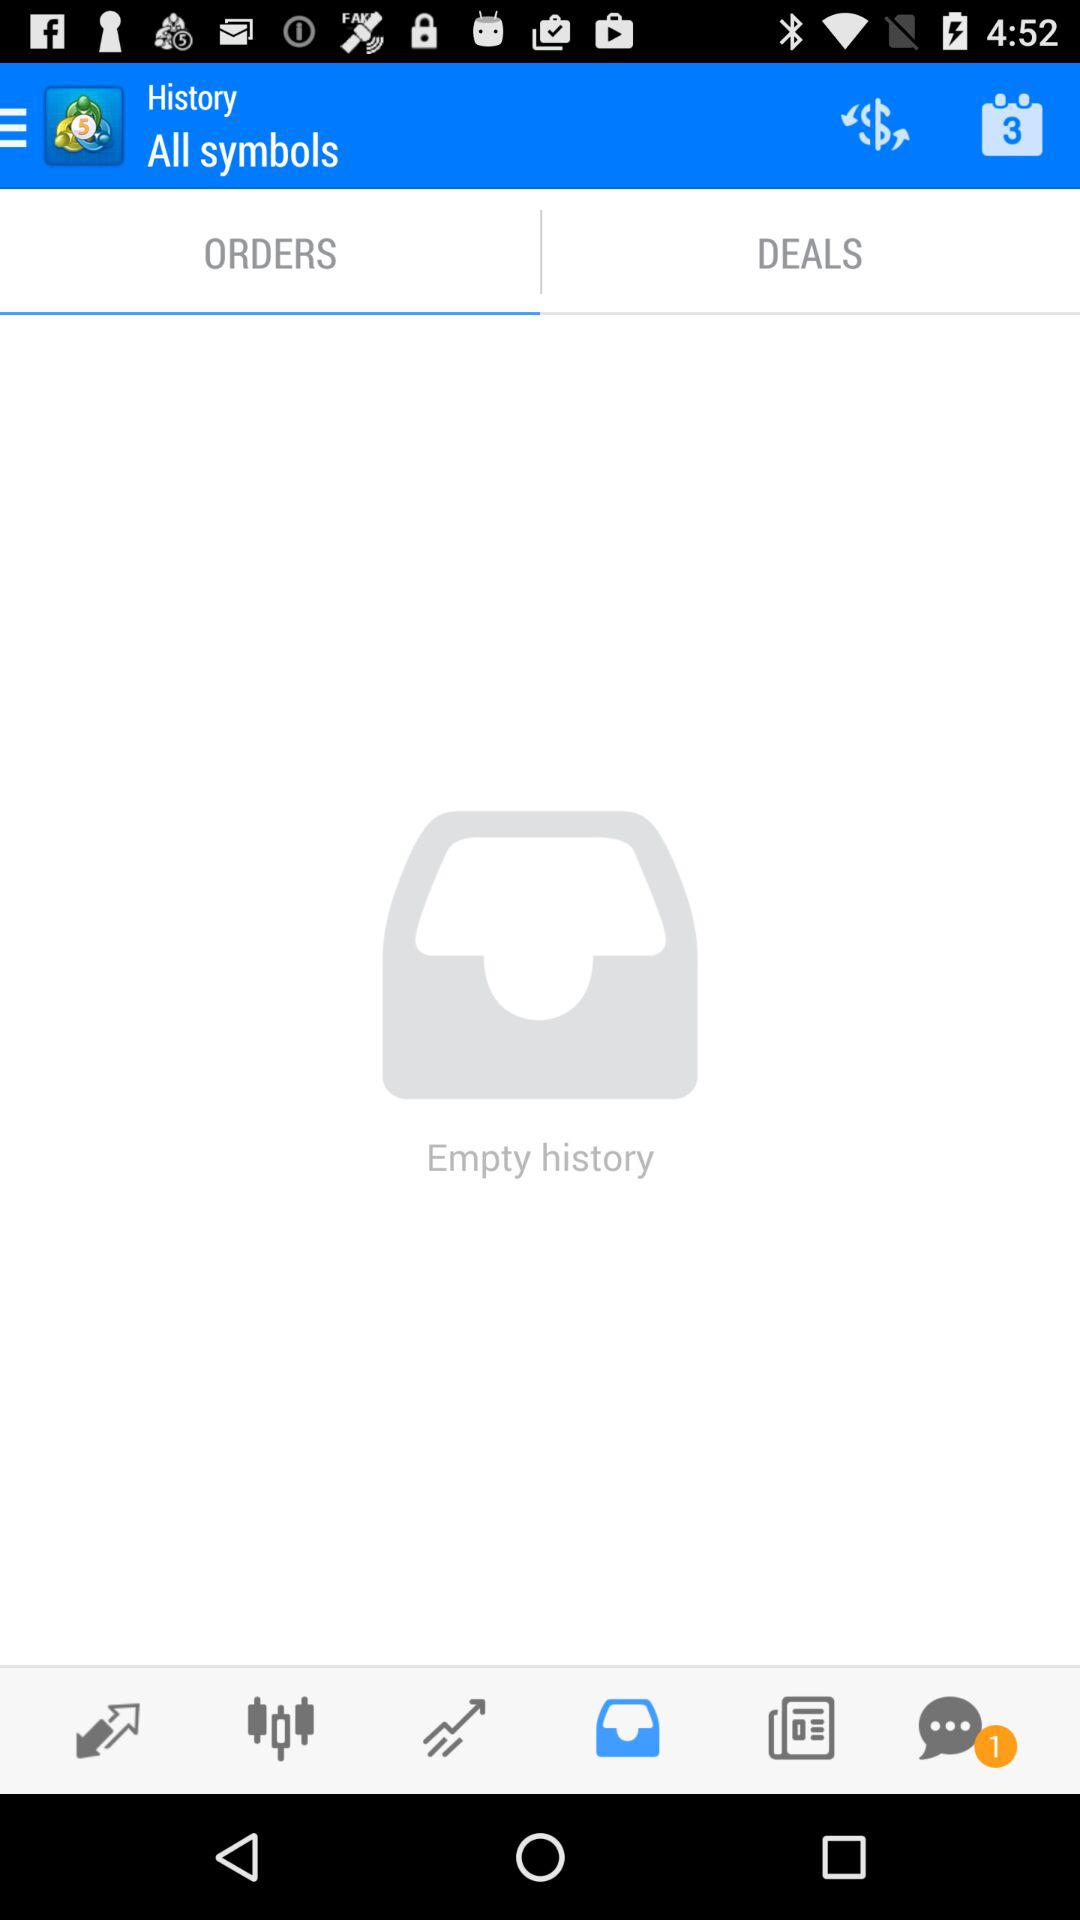What is the app's name? The app's name is "All symbols". 